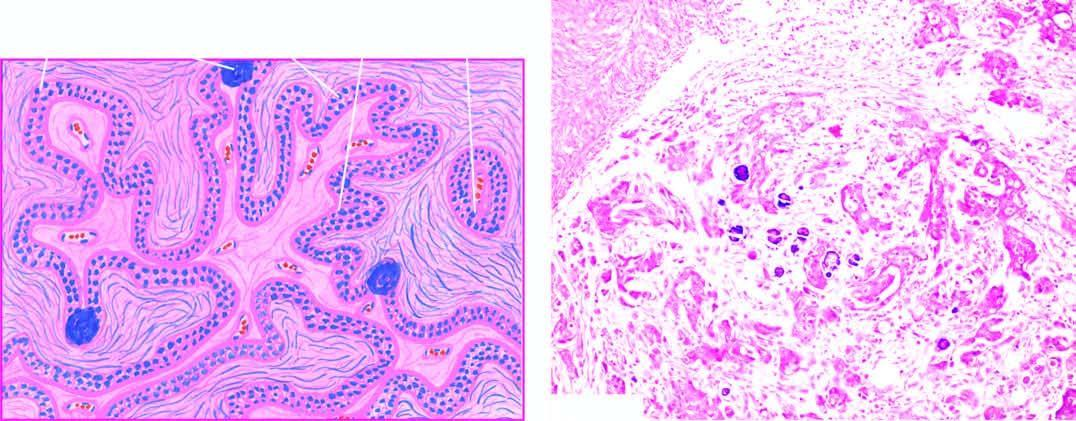do microscopic features include stratification of low columnar epithelium lining the inner surface of the cyst and a few psammoma bodies?
Answer the question using a single word or phrase. Yes 